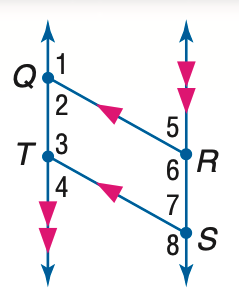Answer the mathemtical geometry problem and directly provide the correct option letter.
Question: In the figure, Q R \parallel T S, Q T \parallel R S, and m \angle 1 = 131. Find the measure of \angle 7.
Choices: A: 39 B: 49 C: 59 D: 131 B 